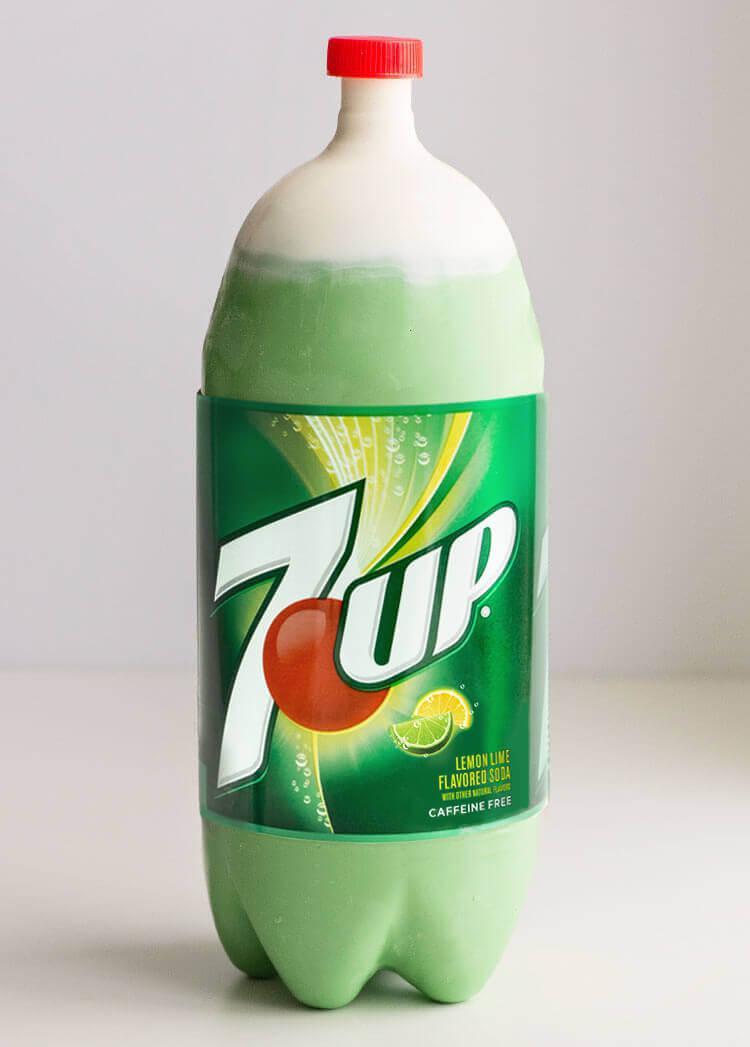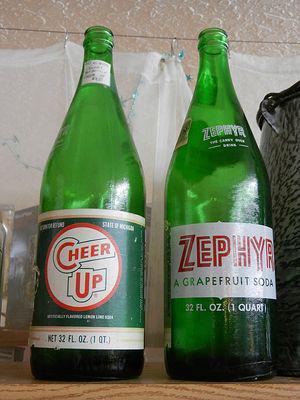The first image is the image on the left, the second image is the image on the right. For the images displayed, is the sentence "An equal number of soda bottles are in each image, all the same brand, but with different labeling in view." factually correct? Answer yes or no. No. The first image is the image on the left, the second image is the image on the right. Evaluate the accuracy of this statement regarding the images: "None of the bottles are capped.". Is it true? Answer yes or no. No. 